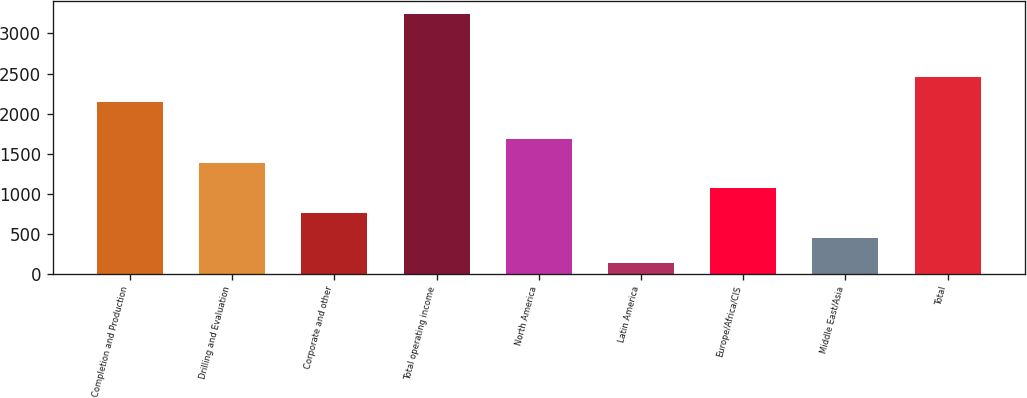Convert chart. <chart><loc_0><loc_0><loc_500><loc_500><bar_chart><fcel>Completion and Production<fcel>Drilling and Evaluation<fcel>Corporate and other<fcel>Total operating income<fcel>North America<fcel>Latin America<fcel>Europe/Africa/CIS<fcel>Middle East/Asia<fcel>Total<nl><fcel>2140<fcel>1376<fcel>753<fcel>3245<fcel>1687.5<fcel>130<fcel>1064.5<fcel>441.5<fcel>2451.5<nl></chart> 